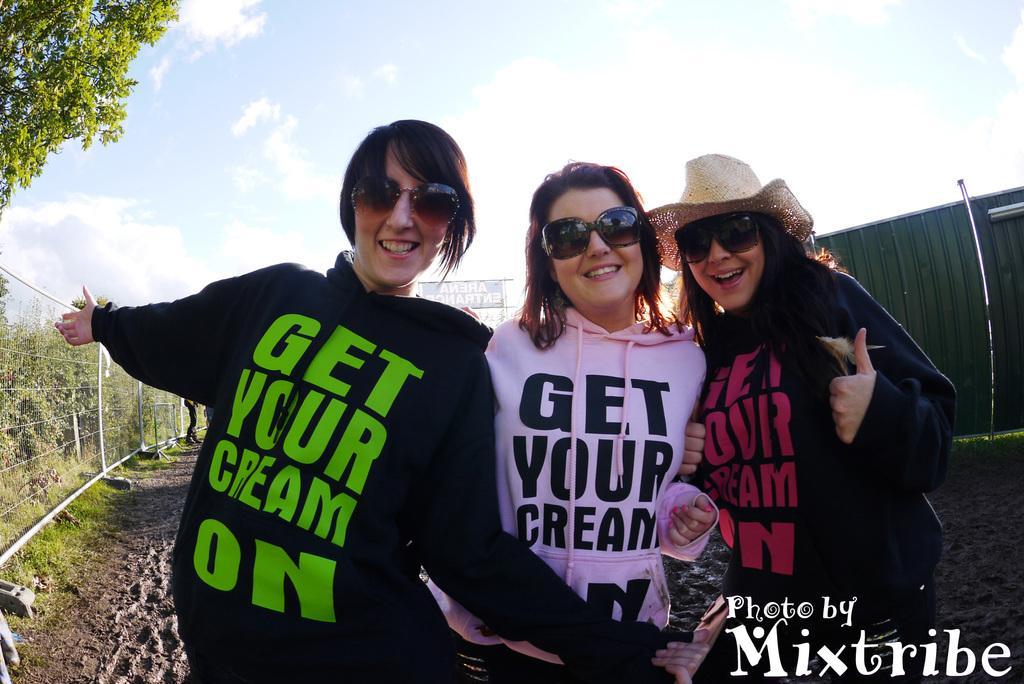In one or two sentences, can you explain what this image depicts? In this image I can see three people with jackets and goggles. I can see one person with the hat. On the jacket I can see the something is written. To the side I can see the railing and the trees. To the right there is a green color gate. In the background there are clouds and the sky. 